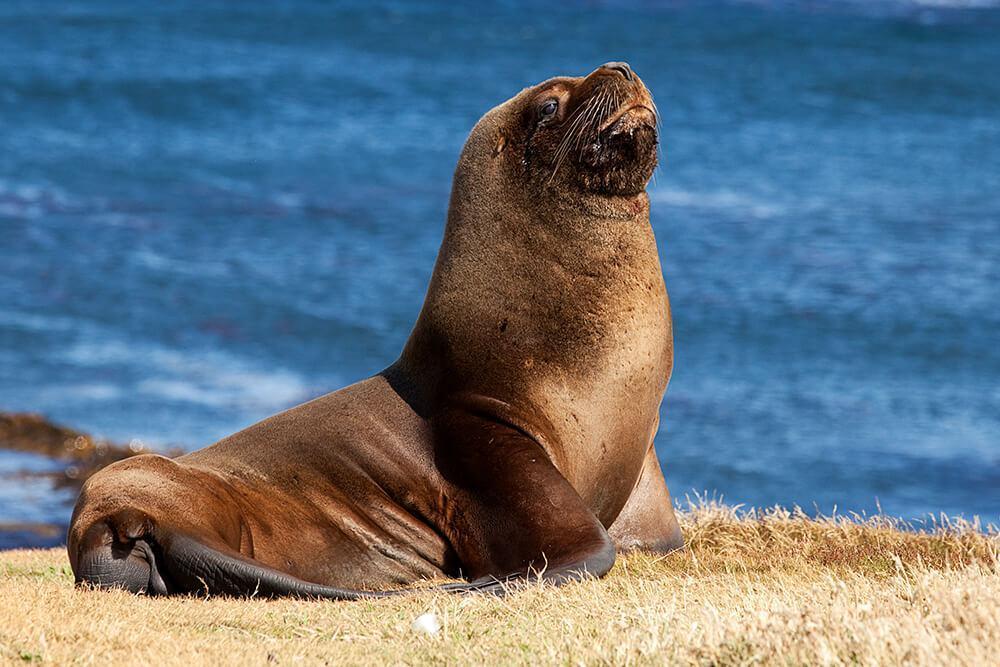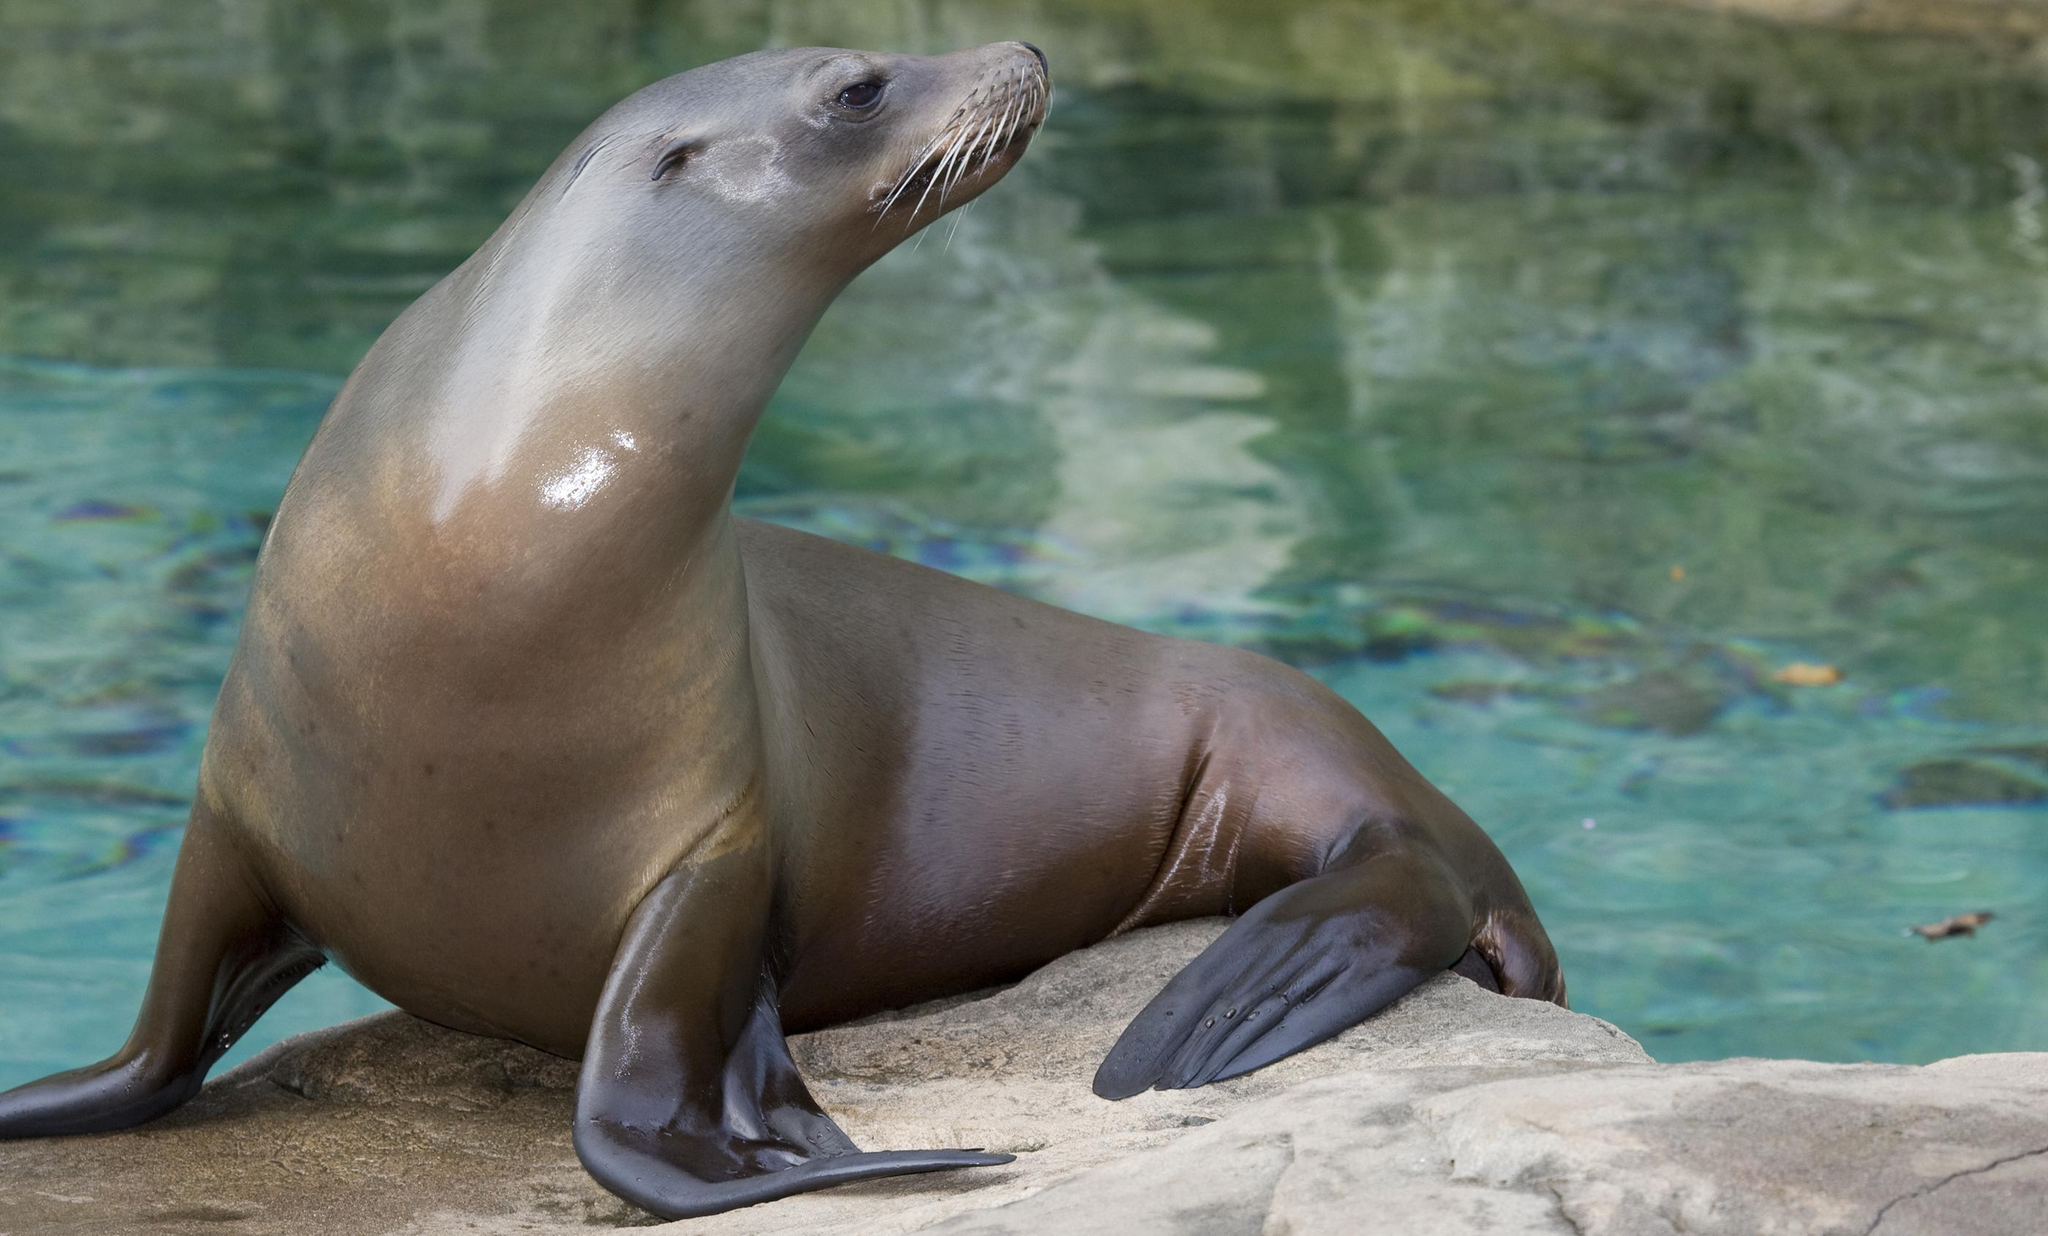The first image is the image on the left, the second image is the image on the right. Considering the images on both sides, is "There is more than one seal in at least one image." valid? Answer yes or no. No. The first image is the image on the left, the second image is the image on the right. For the images shown, is this caption "Two seals appear to be communicating face to face." true? Answer yes or no. No. The first image is the image on the left, the second image is the image on the right. Examine the images to the left and right. Is the description "The lefthand image contains two different-sized seals, both with their heads upright." accurate? Answer yes or no. No. The first image is the image on the left, the second image is the image on the right. Examine the images to the left and right. Is the description "A single wet seal is sunning on a rock alone in the image on the right." accurate? Answer yes or no. Yes. The first image is the image on the left, the second image is the image on the right. Considering the images on both sides, is "The right image shows a seal and no other animal, posed on smooth rock in front of blue-green water." valid? Answer yes or no. Yes. 